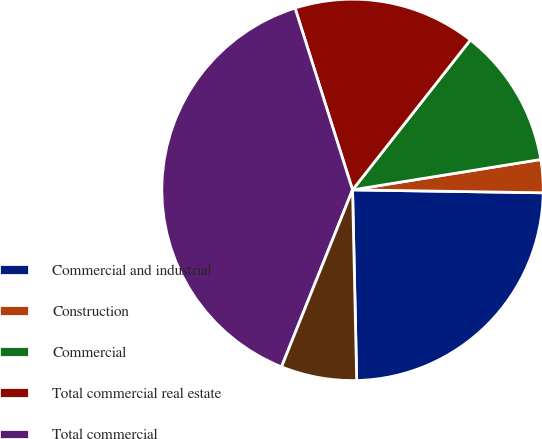Convert chart. <chart><loc_0><loc_0><loc_500><loc_500><pie_chart><fcel>Commercial and industrial<fcel>Construction<fcel>Commercial<fcel>Total commercial real estate<fcel>Total commercial<fcel>Automobile (2)<nl><fcel>24.41%<fcel>2.79%<fcel>11.85%<fcel>15.48%<fcel>39.05%<fcel>6.42%<nl></chart> 